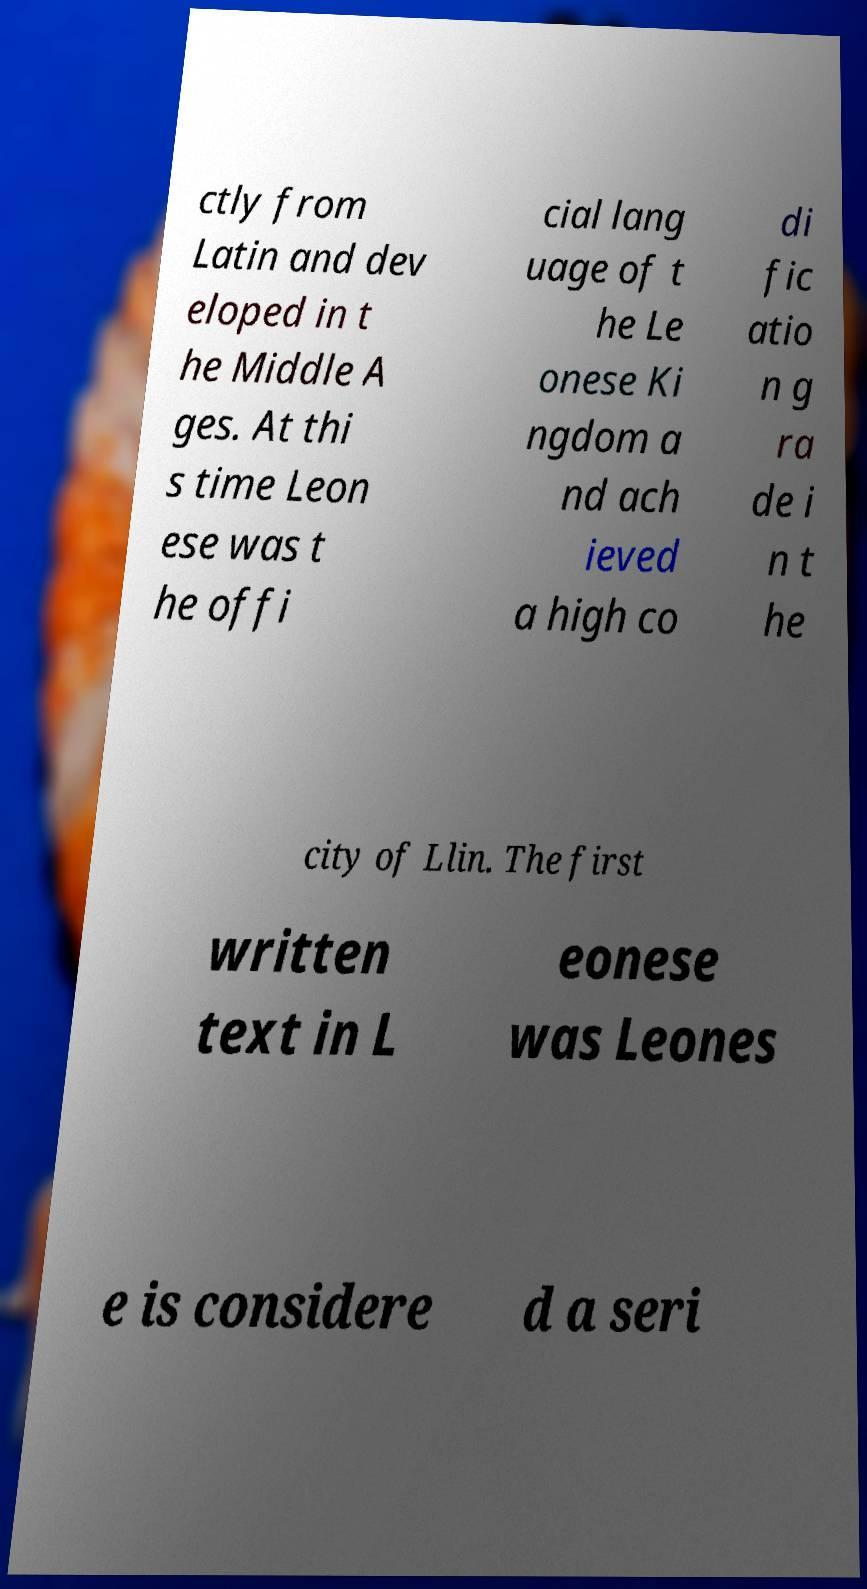Can you read and provide the text displayed in the image?This photo seems to have some interesting text. Can you extract and type it out for me? ctly from Latin and dev eloped in t he Middle A ges. At thi s time Leon ese was t he offi cial lang uage of t he Le onese Ki ngdom a nd ach ieved a high co di fic atio n g ra de i n t he city of Llin. The first written text in L eonese was Leones e is considere d a seri 